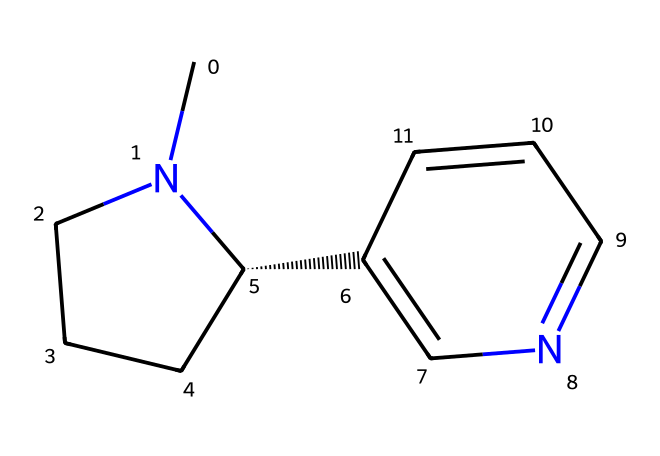What is the name of the chemical represented by the SMILES? The SMILES provided corresponds to nicotine, which is a well-known alkaloid found in tobacco and some e-cigarettes.
Answer: nicotine How many nitrogen atoms are present in the structure? Examining the SMILES, there are two nitrogen atoms indicated by the 'N' characters. Count them in the structure results in a total of two nitrogen atoms.
Answer: 2 What type of alcohol functional group is in the compound? The compound does not contain an alcohol functional group, as there are no -OH groups present in the structure. Instead, it has nitrogen atoms indicating its classification as an alkaloid.
Answer: none What kind of stereochemistry is present in the molecule? The '@' symbol in the SMILES denotes the presence of stereochemistry, indicating a chiral center at that position. This suggests that the molecule has stereoisomers.
Answer: chiral How does nicotine primarily affect the human body? Nicotine primarily acts as a stimulant by binding to nicotinic acetylcholine receptors, leading to increased neurotransmitter release and stimulating the central nervous system.
Answer: stimulant What molecule type is nicotine categorized under based on its nitrogen content? Nicotine is categorized as an alkaloid, which are nitrogen-containing compounds often derived from plants and known for their pharmacological effects.
Answer: alkaloid 